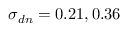Convert formula to latex. <formula><loc_0><loc_0><loc_500><loc_500>\sigma _ { d n } = 0 . 2 1 , 0 . 3 6</formula> 